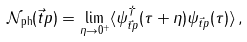<formula> <loc_0><loc_0><loc_500><loc_500>\mathcal { N } _ { \text {ph} } ( \vec { t } { p } ) = \lim _ { \eta \to 0 ^ { + } } \langle \psi ^ { \dag } _ { \vec { t } { p } } ( \tau + \eta ) \psi _ { \vec { t } { p } } ( \tau ) \rangle \, ,</formula> 